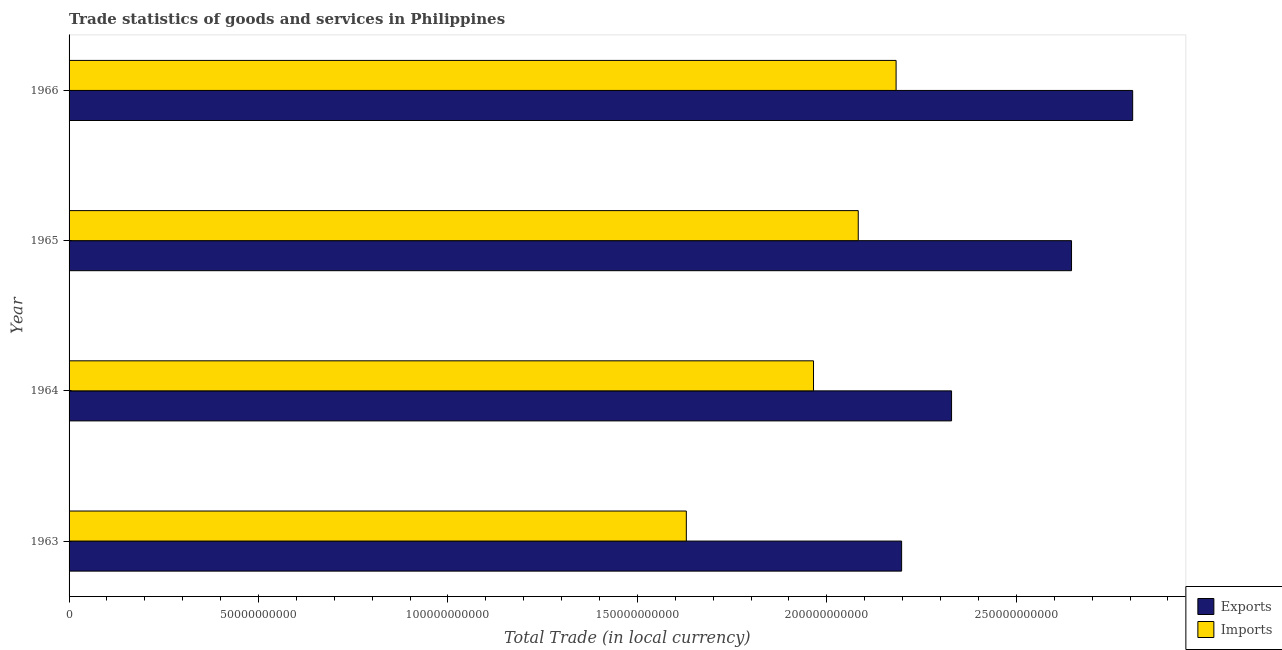How many different coloured bars are there?
Your answer should be compact. 2. How many groups of bars are there?
Ensure brevity in your answer.  4. Are the number of bars per tick equal to the number of legend labels?
Offer a very short reply. Yes. Are the number of bars on each tick of the Y-axis equal?
Your answer should be very brief. Yes. How many bars are there on the 3rd tick from the top?
Your response must be concise. 2. How many bars are there on the 4th tick from the bottom?
Make the answer very short. 2. What is the imports of goods and services in 1964?
Your response must be concise. 1.96e+11. Across all years, what is the maximum export of goods and services?
Your response must be concise. 2.81e+11. Across all years, what is the minimum imports of goods and services?
Your answer should be compact. 1.63e+11. In which year was the imports of goods and services maximum?
Provide a short and direct response. 1966. In which year was the export of goods and services minimum?
Make the answer very short. 1963. What is the total imports of goods and services in the graph?
Provide a short and direct response. 7.86e+11. What is the difference between the imports of goods and services in 1963 and that in 1965?
Keep it short and to the point. -4.54e+1. What is the difference between the imports of goods and services in 1963 and the export of goods and services in 1965?
Give a very brief answer. -1.02e+11. What is the average export of goods and services per year?
Make the answer very short. 2.49e+11. In the year 1964, what is the difference between the imports of goods and services and export of goods and services?
Give a very brief answer. -3.64e+1. In how many years, is the export of goods and services greater than 260000000000 LCU?
Ensure brevity in your answer.  2. What is the ratio of the imports of goods and services in 1964 to that in 1965?
Keep it short and to the point. 0.94. What is the difference between the highest and the second highest imports of goods and services?
Your answer should be very brief. 9.99e+09. What is the difference between the highest and the lowest export of goods and services?
Ensure brevity in your answer.  6.10e+1. What does the 2nd bar from the top in 1966 represents?
Give a very brief answer. Exports. What does the 1st bar from the bottom in 1964 represents?
Ensure brevity in your answer.  Exports. How many bars are there?
Make the answer very short. 8. Are all the bars in the graph horizontal?
Give a very brief answer. Yes. Does the graph contain any zero values?
Keep it short and to the point. No. Does the graph contain grids?
Offer a very short reply. No. Where does the legend appear in the graph?
Give a very brief answer. Bottom right. How many legend labels are there?
Provide a short and direct response. 2. What is the title of the graph?
Give a very brief answer. Trade statistics of goods and services in Philippines. What is the label or title of the X-axis?
Your answer should be very brief. Total Trade (in local currency). What is the Total Trade (in local currency) in Exports in 1963?
Ensure brevity in your answer.  2.20e+11. What is the Total Trade (in local currency) in Imports in 1963?
Make the answer very short. 1.63e+11. What is the Total Trade (in local currency) in Exports in 1964?
Give a very brief answer. 2.33e+11. What is the Total Trade (in local currency) in Imports in 1964?
Offer a terse response. 1.96e+11. What is the Total Trade (in local currency) of Exports in 1965?
Provide a succinct answer. 2.65e+11. What is the Total Trade (in local currency) in Imports in 1965?
Your response must be concise. 2.08e+11. What is the Total Trade (in local currency) of Exports in 1966?
Your answer should be very brief. 2.81e+11. What is the Total Trade (in local currency) of Imports in 1966?
Offer a very short reply. 2.18e+11. Across all years, what is the maximum Total Trade (in local currency) of Exports?
Give a very brief answer. 2.81e+11. Across all years, what is the maximum Total Trade (in local currency) of Imports?
Your response must be concise. 2.18e+11. Across all years, what is the minimum Total Trade (in local currency) of Exports?
Keep it short and to the point. 2.20e+11. Across all years, what is the minimum Total Trade (in local currency) of Imports?
Offer a terse response. 1.63e+11. What is the total Total Trade (in local currency) in Exports in the graph?
Provide a succinct answer. 9.98e+11. What is the total Total Trade (in local currency) in Imports in the graph?
Offer a terse response. 7.86e+11. What is the difference between the Total Trade (in local currency) of Exports in 1963 and that in 1964?
Offer a very short reply. -1.32e+1. What is the difference between the Total Trade (in local currency) of Imports in 1963 and that in 1964?
Your answer should be very brief. -3.36e+1. What is the difference between the Total Trade (in local currency) of Exports in 1963 and that in 1965?
Offer a terse response. -4.48e+1. What is the difference between the Total Trade (in local currency) of Imports in 1963 and that in 1965?
Your answer should be very brief. -4.54e+1. What is the difference between the Total Trade (in local currency) in Exports in 1963 and that in 1966?
Make the answer very short. -6.10e+1. What is the difference between the Total Trade (in local currency) of Imports in 1963 and that in 1966?
Provide a succinct answer. -5.54e+1. What is the difference between the Total Trade (in local currency) of Exports in 1964 and that in 1965?
Your response must be concise. -3.17e+1. What is the difference between the Total Trade (in local currency) in Imports in 1964 and that in 1965?
Your answer should be very brief. -1.18e+1. What is the difference between the Total Trade (in local currency) in Exports in 1964 and that in 1966?
Provide a succinct answer. -4.78e+1. What is the difference between the Total Trade (in local currency) of Imports in 1964 and that in 1966?
Your answer should be compact. -2.18e+1. What is the difference between the Total Trade (in local currency) of Exports in 1965 and that in 1966?
Ensure brevity in your answer.  -1.61e+1. What is the difference between the Total Trade (in local currency) of Imports in 1965 and that in 1966?
Give a very brief answer. -9.99e+09. What is the difference between the Total Trade (in local currency) of Exports in 1963 and the Total Trade (in local currency) of Imports in 1964?
Your answer should be compact. 2.33e+1. What is the difference between the Total Trade (in local currency) in Exports in 1963 and the Total Trade (in local currency) in Imports in 1965?
Offer a terse response. 1.15e+1. What is the difference between the Total Trade (in local currency) in Exports in 1963 and the Total Trade (in local currency) in Imports in 1966?
Offer a terse response. 1.46e+09. What is the difference between the Total Trade (in local currency) in Exports in 1964 and the Total Trade (in local currency) in Imports in 1965?
Your answer should be very brief. 2.46e+1. What is the difference between the Total Trade (in local currency) of Exports in 1964 and the Total Trade (in local currency) of Imports in 1966?
Offer a terse response. 1.46e+1. What is the difference between the Total Trade (in local currency) of Exports in 1965 and the Total Trade (in local currency) of Imports in 1966?
Your answer should be very brief. 4.63e+1. What is the average Total Trade (in local currency) of Exports per year?
Ensure brevity in your answer.  2.49e+11. What is the average Total Trade (in local currency) in Imports per year?
Ensure brevity in your answer.  1.96e+11. In the year 1963, what is the difference between the Total Trade (in local currency) in Exports and Total Trade (in local currency) in Imports?
Provide a succinct answer. 5.68e+1. In the year 1964, what is the difference between the Total Trade (in local currency) in Exports and Total Trade (in local currency) in Imports?
Keep it short and to the point. 3.64e+1. In the year 1965, what is the difference between the Total Trade (in local currency) in Exports and Total Trade (in local currency) in Imports?
Give a very brief answer. 5.63e+1. In the year 1966, what is the difference between the Total Trade (in local currency) of Exports and Total Trade (in local currency) of Imports?
Offer a terse response. 6.24e+1. What is the ratio of the Total Trade (in local currency) of Exports in 1963 to that in 1964?
Provide a succinct answer. 0.94. What is the ratio of the Total Trade (in local currency) in Imports in 1963 to that in 1964?
Make the answer very short. 0.83. What is the ratio of the Total Trade (in local currency) of Exports in 1963 to that in 1965?
Keep it short and to the point. 0.83. What is the ratio of the Total Trade (in local currency) of Imports in 1963 to that in 1965?
Your response must be concise. 0.78. What is the ratio of the Total Trade (in local currency) in Exports in 1963 to that in 1966?
Your answer should be compact. 0.78. What is the ratio of the Total Trade (in local currency) of Imports in 1963 to that in 1966?
Offer a very short reply. 0.75. What is the ratio of the Total Trade (in local currency) of Exports in 1964 to that in 1965?
Make the answer very short. 0.88. What is the ratio of the Total Trade (in local currency) in Imports in 1964 to that in 1965?
Offer a very short reply. 0.94. What is the ratio of the Total Trade (in local currency) of Exports in 1964 to that in 1966?
Your answer should be very brief. 0.83. What is the ratio of the Total Trade (in local currency) in Imports in 1964 to that in 1966?
Provide a short and direct response. 0.9. What is the ratio of the Total Trade (in local currency) in Exports in 1965 to that in 1966?
Provide a succinct answer. 0.94. What is the ratio of the Total Trade (in local currency) of Imports in 1965 to that in 1966?
Your answer should be very brief. 0.95. What is the difference between the highest and the second highest Total Trade (in local currency) of Exports?
Your answer should be compact. 1.61e+1. What is the difference between the highest and the second highest Total Trade (in local currency) of Imports?
Provide a succinct answer. 9.99e+09. What is the difference between the highest and the lowest Total Trade (in local currency) of Exports?
Keep it short and to the point. 6.10e+1. What is the difference between the highest and the lowest Total Trade (in local currency) of Imports?
Provide a succinct answer. 5.54e+1. 